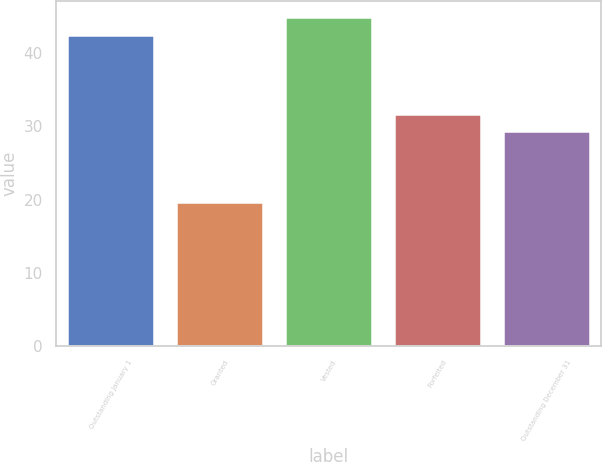Convert chart. <chart><loc_0><loc_0><loc_500><loc_500><bar_chart><fcel>Outstanding January 1<fcel>Granted<fcel>Vested<fcel>Forfeited<fcel>Outstanding December 31<nl><fcel>42.53<fcel>19.68<fcel>44.9<fcel>31.69<fcel>29.32<nl></chart> 